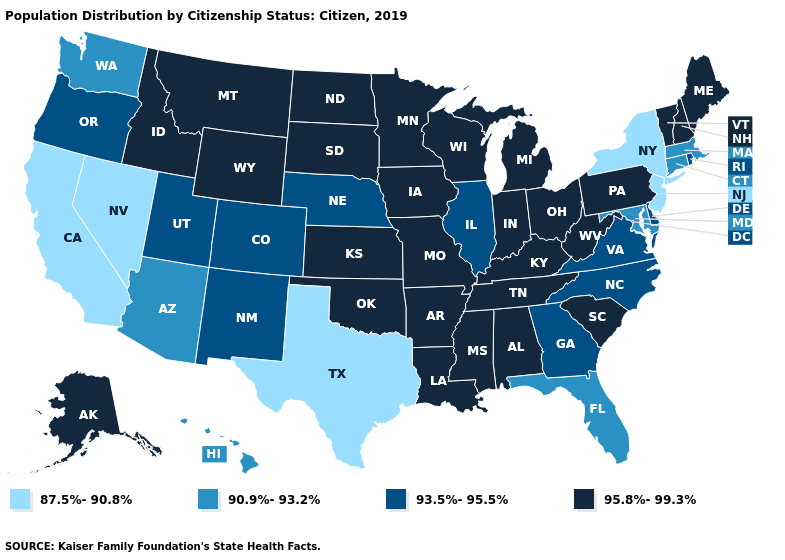Among the states that border Connecticut , does Massachusetts have the highest value?
Keep it brief. No. What is the lowest value in the West?
Keep it brief. 87.5%-90.8%. What is the value of Oregon?
Concise answer only. 93.5%-95.5%. Among the states that border Virginia , which have the lowest value?
Be succinct. Maryland. What is the lowest value in states that border Georgia?
Quick response, please. 90.9%-93.2%. Which states have the highest value in the USA?
Keep it brief. Alabama, Alaska, Arkansas, Idaho, Indiana, Iowa, Kansas, Kentucky, Louisiana, Maine, Michigan, Minnesota, Mississippi, Missouri, Montana, New Hampshire, North Dakota, Ohio, Oklahoma, Pennsylvania, South Carolina, South Dakota, Tennessee, Vermont, West Virginia, Wisconsin, Wyoming. What is the value of Connecticut?
Be succinct. 90.9%-93.2%. What is the value of Texas?
Keep it brief. 87.5%-90.8%. Does North Carolina have the highest value in the USA?
Quick response, please. No. Which states have the lowest value in the USA?
Answer briefly. California, Nevada, New Jersey, New York, Texas. Name the states that have a value in the range 93.5%-95.5%?
Write a very short answer. Colorado, Delaware, Georgia, Illinois, Nebraska, New Mexico, North Carolina, Oregon, Rhode Island, Utah, Virginia. What is the value of Massachusetts?
Keep it brief. 90.9%-93.2%. Among the states that border New Mexico , which have the lowest value?
Write a very short answer. Texas. How many symbols are there in the legend?
Write a very short answer. 4. 